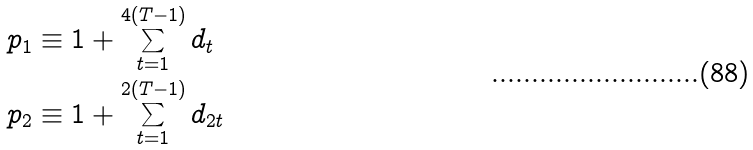Convert formula to latex. <formula><loc_0><loc_0><loc_500><loc_500>p _ { 1 } & \equiv 1 + \sum _ { t = 1 } ^ { 4 ( T - 1 ) } { d _ { t } } \\ p _ { 2 } & \equiv 1 + \sum _ { t = 1 } ^ { 2 ( T - 1 ) } { d _ { 2 t } }</formula> 